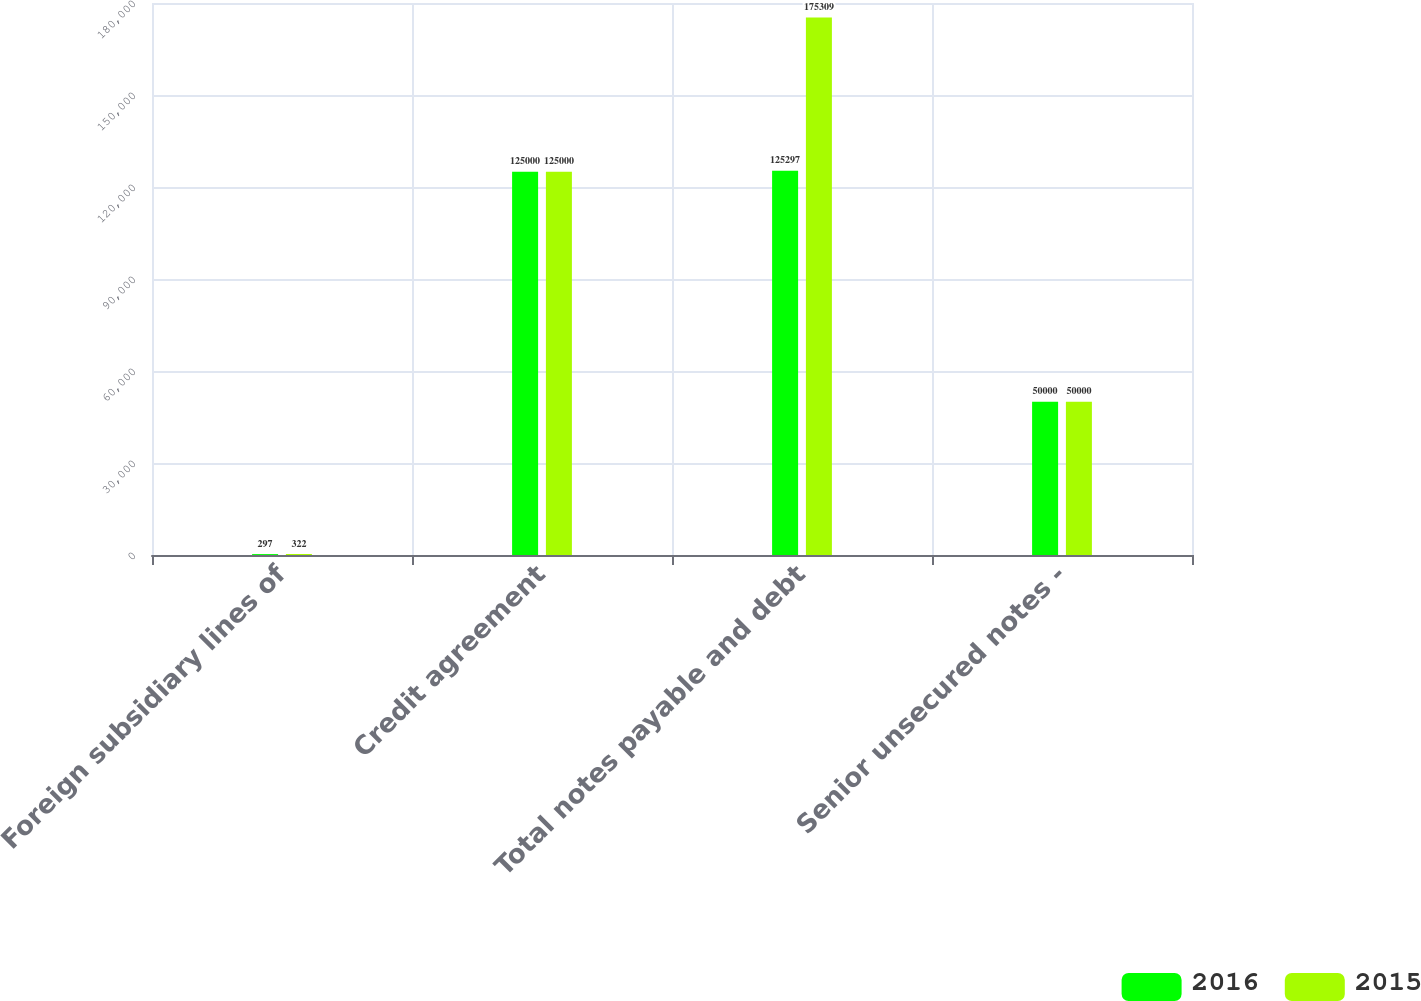<chart> <loc_0><loc_0><loc_500><loc_500><stacked_bar_chart><ecel><fcel>Foreign subsidiary lines of<fcel>Credit agreement<fcel>Total notes payable and debt<fcel>Senior unsecured notes -<nl><fcel>2016<fcel>297<fcel>125000<fcel>125297<fcel>50000<nl><fcel>2015<fcel>322<fcel>125000<fcel>175309<fcel>50000<nl></chart> 